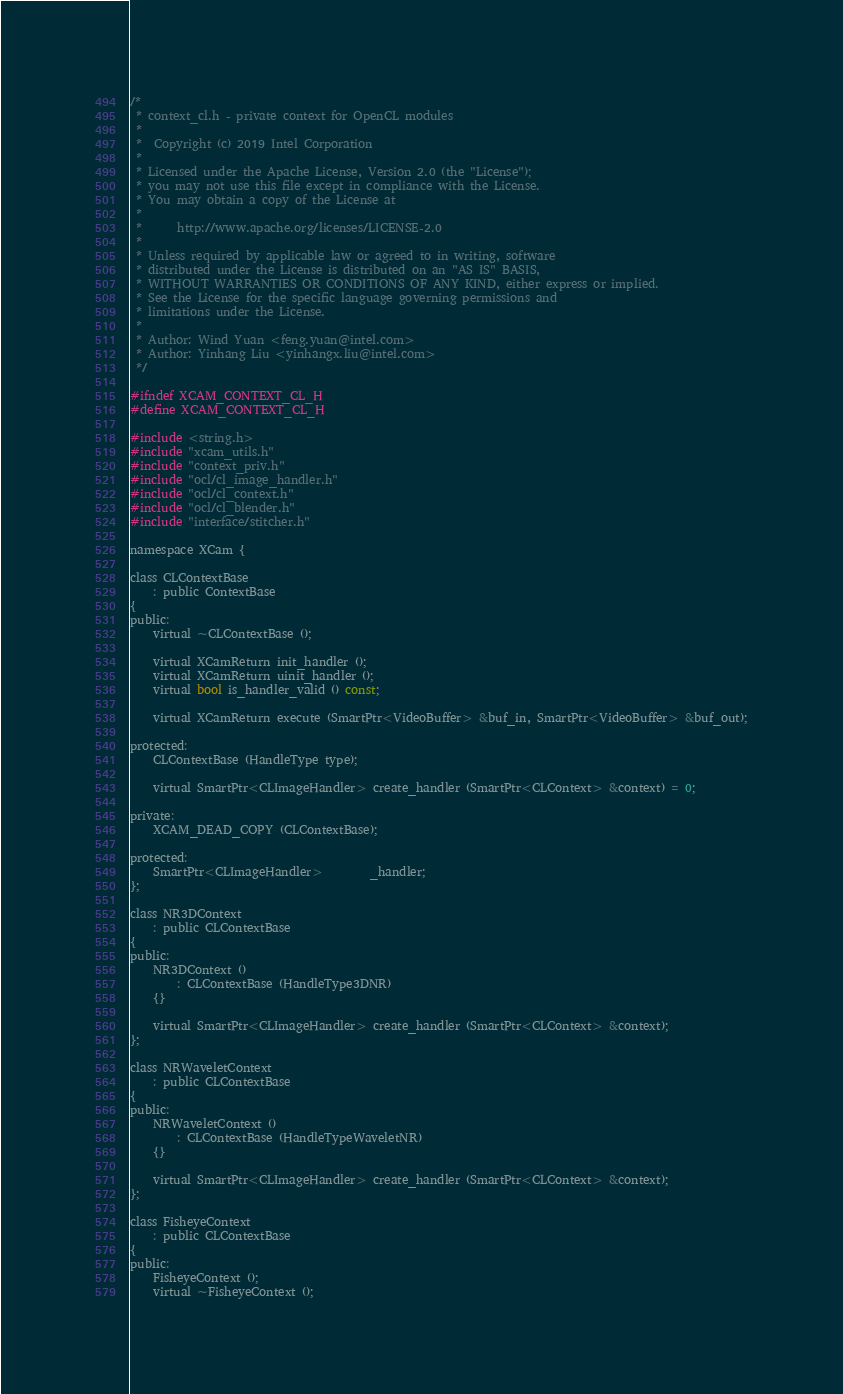<code> <loc_0><loc_0><loc_500><loc_500><_C_>/*
 * context_cl.h - private context for OpenCL modules
 *
 *  Copyright (c) 2019 Intel Corporation
 *
 * Licensed under the Apache License, Version 2.0 (the "License");
 * you may not use this file except in compliance with the License.
 * You may obtain a copy of the License at
 *
 *      http://www.apache.org/licenses/LICENSE-2.0
 *
 * Unless required by applicable law or agreed to in writing, software
 * distributed under the License is distributed on an "AS IS" BASIS,
 * WITHOUT WARRANTIES OR CONDITIONS OF ANY KIND, either express or implied.
 * See the License for the specific language governing permissions and
 * limitations under the License.
 *
 * Author: Wind Yuan <feng.yuan@intel.com>
 * Author: Yinhang Liu <yinhangx.liu@intel.com>
 */

#ifndef XCAM_CONTEXT_CL_H
#define XCAM_CONTEXT_CL_H

#include <string.h>
#include "xcam_utils.h"
#include "context_priv.h"
#include "ocl/cl_image_handler.h"
#include "ocl/cl_context.h"
#include "ocl/cl_blender.h"
#include "interface/stitcher.h"

namespace XCam {

class CLContextBase
    : public ContextBase
{
public:
    virtual ~CLContextBase ();

    virtual XCamReturn init_handler ();
    virtual XCamReturn uinit_handler ();
    virtual bool is_handler_valid () const;

    virtual XCamReturn execute (SmartPtr<VideoBuffer> &buf_in, SmartPtr<VideoBuffer> &buf_out);

protected:
    CLContextBase (HandleType type);

    virtual SmartPtr<CLImageHandler> create_handler (SmartPtr<CLContext> &context) = 0;

private:
    XCAM_DEAD_COPY (CLContextBase);

protected:
    SmartPtr<CLImageHandler>        _handler;
};

class NR3DContext
    : public CLContextBase
{
public:
    NR3DContext ()
        : CLContextBase (HandleType3DNR)
    {}

    virtual SmartPtr<CLImageHandler> create_handler (SmartPtr<CLContext> &context);
};

class NRWaveletContext
    : public CLContextBase
{
public:
    NRWaveletContext ()
        : CLContextBase (HandleTypeWaveletNR)
    {}

    virtual SmartPtr<CLImageHandler> create_handler (SmartPtr<CLContext> &context);
};

class FisheyeContext
    : public CLContextBase
{
public:
    FisheyeContext ();
    virtual ~FisheyeContext ();
</code> 